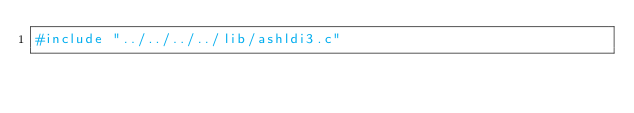<code> <loc_0><loc_0><loc_500><loc_500><_C_>#include "../../../../lib/ashldi3.c"
</code> 